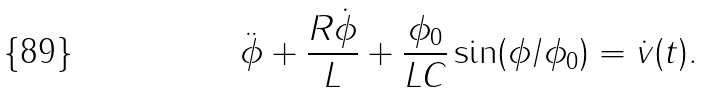Convert formula to latex. <formula><loc_0><loc_0><loc_500><loc_500>\ddot { \phi } + \frac { R \dot { \phi } } { L } + \frac { \phi _ { 0 } } { L C } \sin ( \phi / \phi _ { 0 } ) = \dot { v } ( t ) .</formula> 